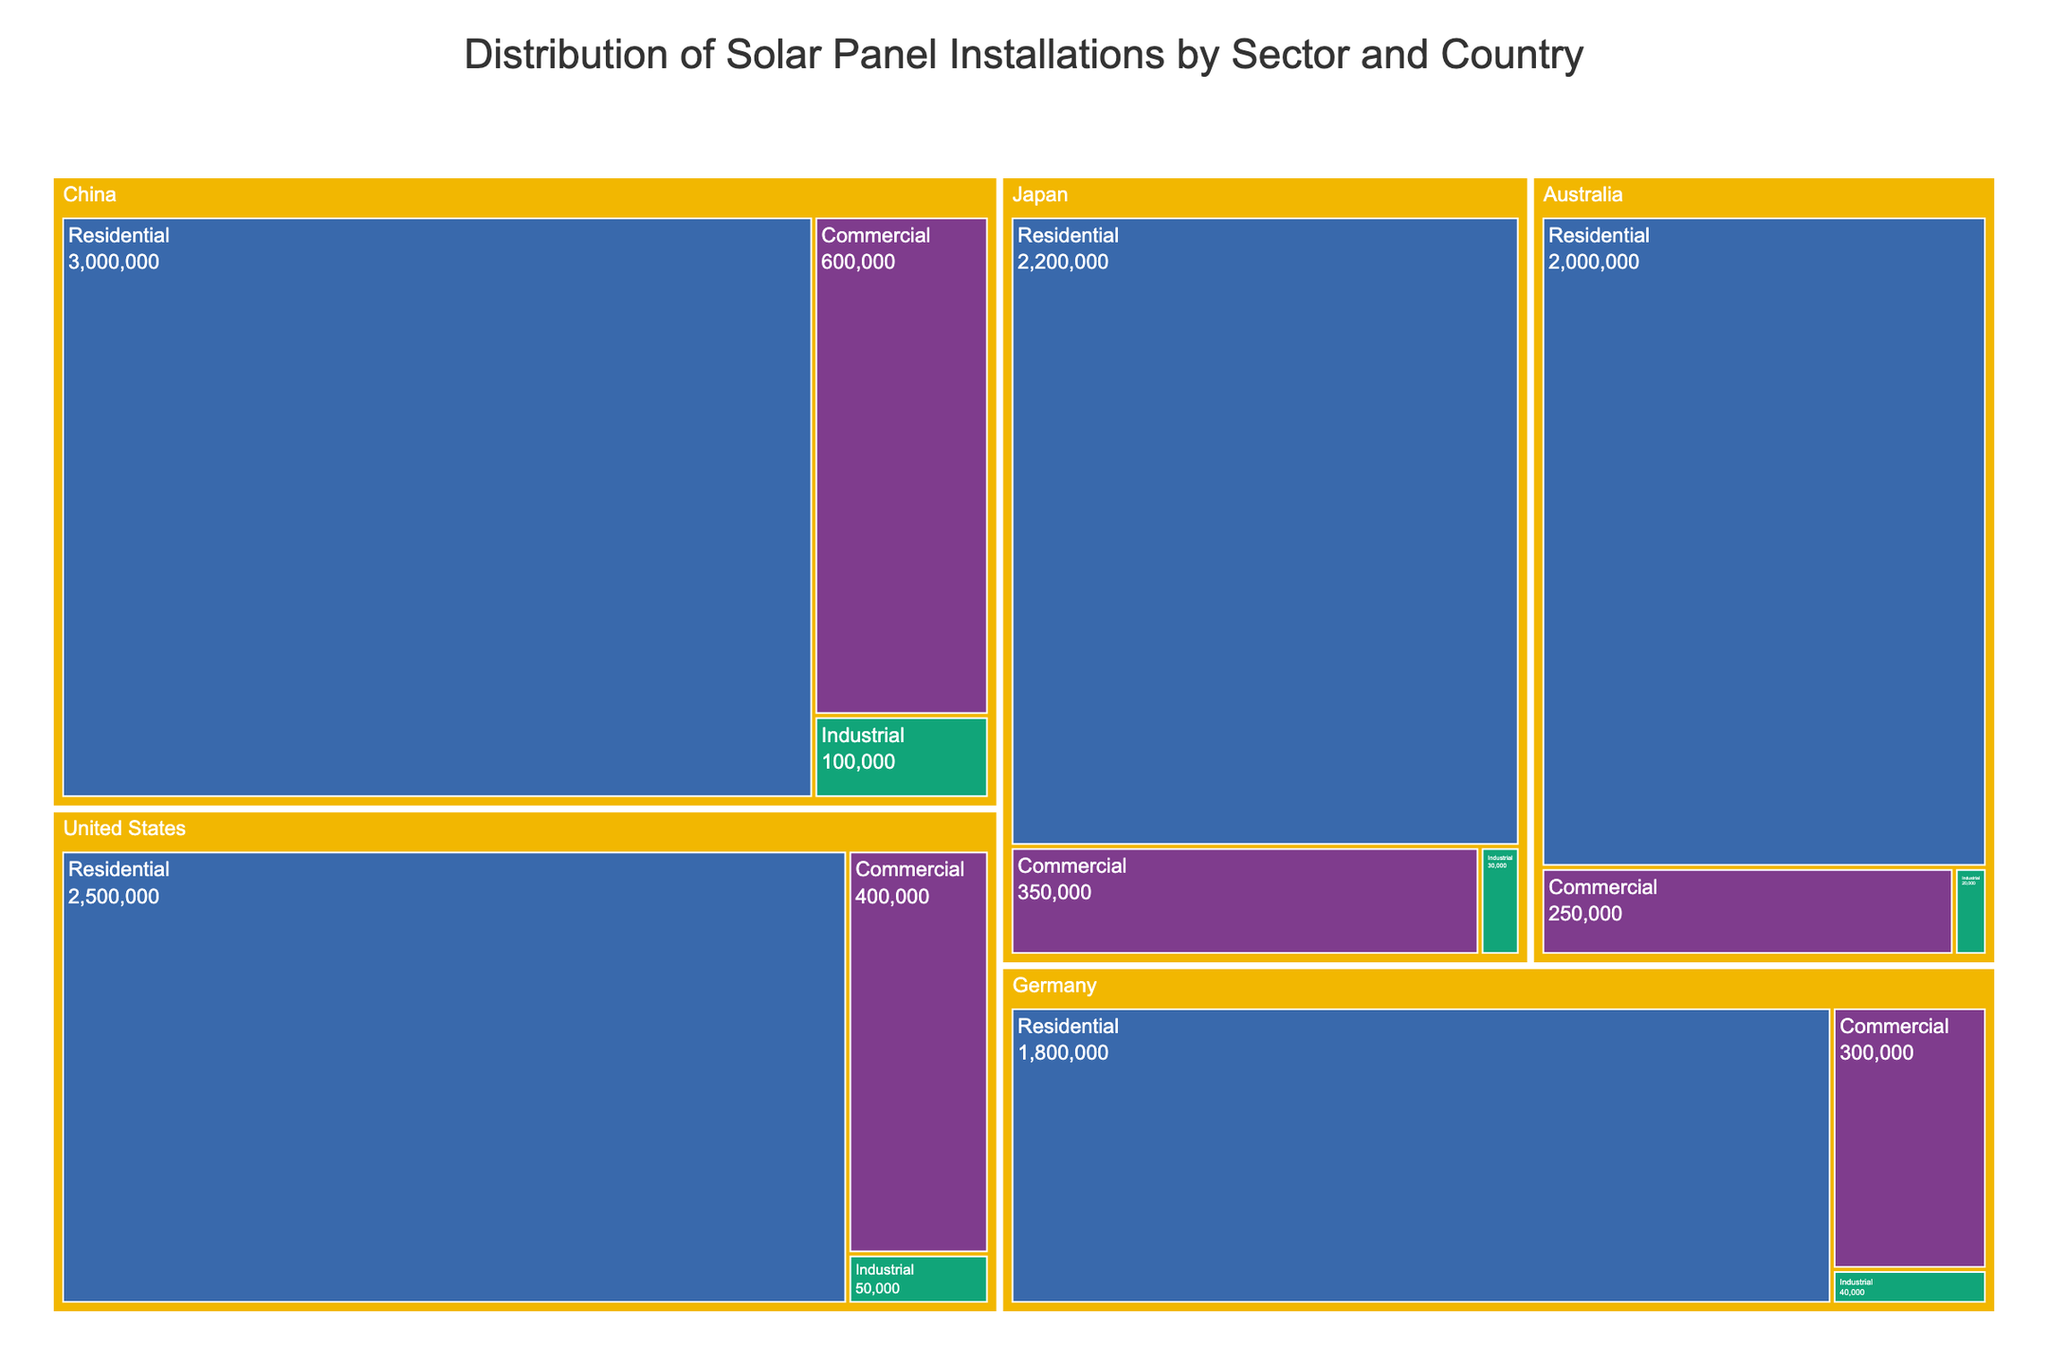What's the title of the figure? The title is usually located at the top of the figure. It is centered and typically in a larger font size. In this case, it states: "Distribution of Solar Panel Installations by Sector and Country"
Answer: Distribution of Solar Panel Installations by Sector and Country What color represents the Residential sector? The color for each sector is provided in the legend or indicated in the treemap itself. Observing the treemap, the color assigned to the Residential sector can be seen.
Answer: #FFA07A (orange) Which country has the highest number of residential solar panel installations? To determine this, locate the sections for the Residential sector in the treemap and compare their values. The country with the largest numerical value is the one with the highest installations. In this case, it's China with 3,000,000 installations.
Answer: China What's the combined total number of Commercial and Industrial installations in Japan? Sum the number of Commercial and Industrial installations in Japan. Refer to the respective sectors in the treemap. Commercial installations in Japan are 350,000, and Industrial installations are 30,000. Adding these gives:
350,000 + 30,000 = 380,000
Answer: 380,000 Which country has fewer industrial installations, Australia or Germany, and by how much? Compare the Industrial sector installations for both countries in the treemap. Australia's Industrial installations are 20,000, and Germany's are 40,000. Subtract Australia's number from Germany's number to find the difference:
40,000 - 20,000 = 20,000
Answer: Australia, by 20,000 What proportion of the total Residential installations does the United States account for? First, find the total number of Residential installations by summing up the values for each country. Then calculate the proportion that the United States' value represents. 
Total Residential installations: 
2,500,000 (US) + 3,000,000 (China) + 1,800,000 (Germany) + 2,200,000 (Japan) + 2,000,000 (Australia) 
= 11,500,000
Proportion for the US: 
2,500,000 / 11,500,000 = 0.2174
Multiply by 100 to get the percentage: 
0.2174 * 100 = 21.74%
Answer: 21.74% 